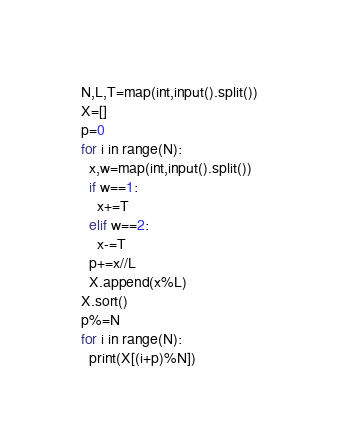<code> <loc_0><loc_0><loc_500><loc_500><_Python_>N,L,T=map(int,input().split())
X=[]
p=0
for i in range(N):
  x,w=map(int,input().split())
  if w==1:
    x+=T
  elif w==2:
    x-=T
  p+=x//L
  X.append(x%L)
X.sort()
p%=N
for i in range(N):
  print(X[(i+p)%N])</code> 